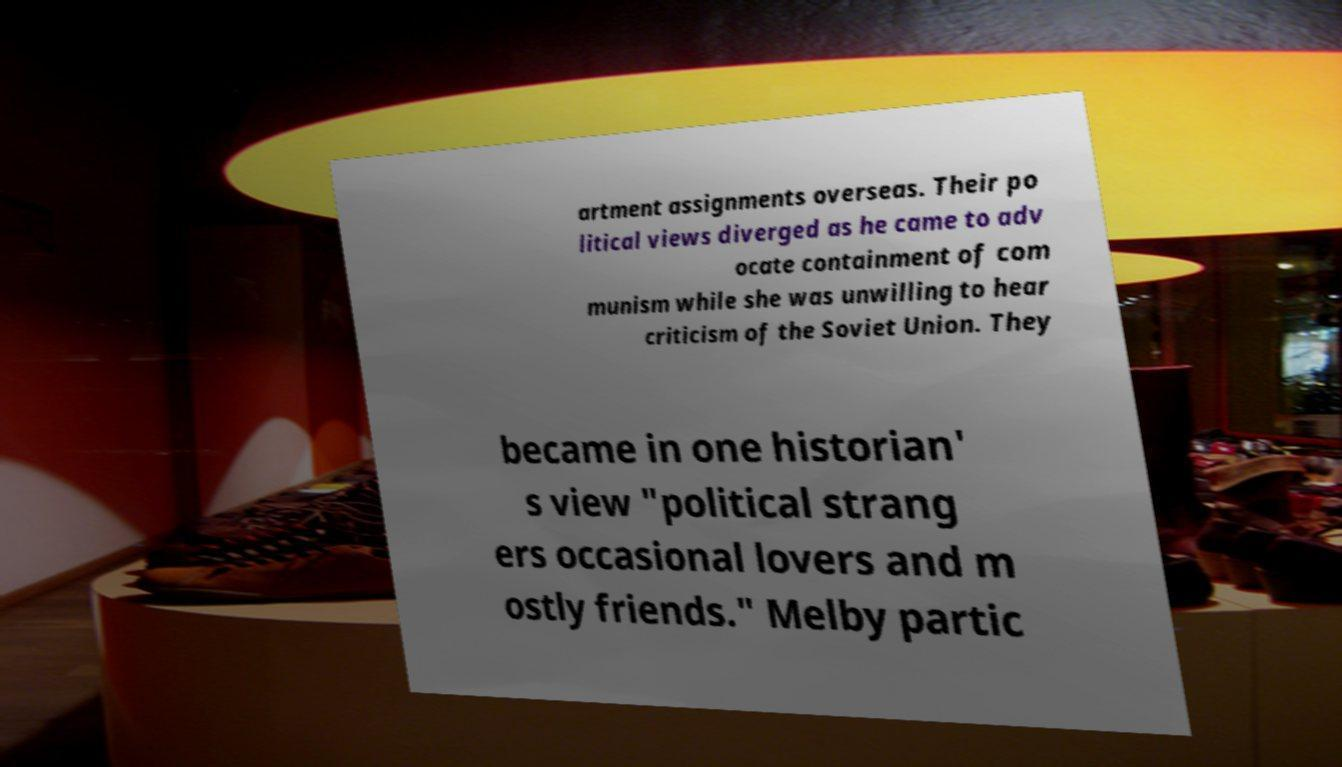What messages or text are displayed in this image? I need them in a readable, typed format. artment assignments overseas. Their po litical views diverged as he came to adv ocate containment of com munism while she was unwilling to hear criticism of the Soviet Union. They became in one historian' s view "political strang ers occasional lovers and m ostly friends." Melby partic 